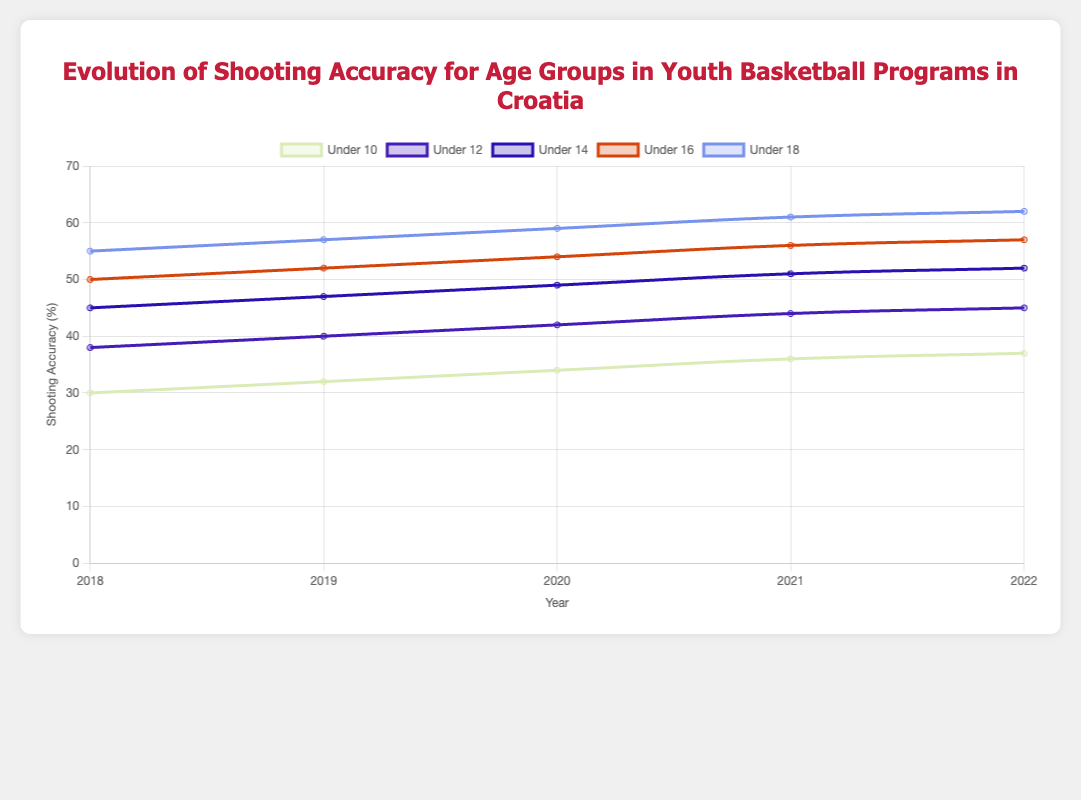What is the overall trend in shooting accuracy for the "Under 10" age group from 2018 to 2022? The "Under 10" age group shows a clear upward trend. Starting at 30% in 2018, it increases to 32% in 2019, 34% in 2020, 36% in 2021, and reaches 37% in 2022.
Answer: Upward trend Which age group has the highest shooting accuracy in 2022? By observing the final data points for each age group in 2022, the "Under 18" age group has the highest shooting accuracy at 62%.
Answer: Under 18 Between "Under 12" and "Under 14" age groups, which showed more improvement in shooting accuracy from 2018 to 2022? The "Under 12" group improved from 38% to 45%, a 7% increase, while the "Under 14" group went from 45% to 52%, also a 7% increase. Both age groups showed equal improvement of 7%.
Answer: Equal improvement What was the average shooting accuracy for the "Under 16" age group over the years 2018 to 2022? The shooting accuracies are 50, 52, 54, 56, and 57 for the given years. Adding these gives (50 + 52 + 54 + 56 + 57) = 269. There are 5 years, so the average is 269 / 5 = 53.8%.
Answer: 53.8% How much did the shooting accuracy for the "Under 18" age group increase between 2020 and 2021? The "Under 18" shooting accuracy in 2020 was 59%, and in 2021 it was 61%. The increase is 61 - 59 = 2%.
Answer: 2% Which age group shows the least improvement in shooting accuracy between 2018 and 2022? The "Under 10" age group improves from 30% to 37%, which is a 7% increase, the least compared to other groups.
Answer: Under 10 Is there any year where all age groups show an improvement in shooting accuracy compared to the previous year? Examining the shooting accuracies year-by-year for each age group reveals that in 2019, all age groups ("Under 10," "Under 12," "Under 14," "Under 16," "Under 18") show an increase compared to 2018. Each group's accuracy rises consistently over the years.
Answer: 2019 What is the difference in shooting accuracy between the "Under 12" and "Under 16" age groups in 2022? In 2022, the "Under 12" age group's shooting accuracy is 45%, and the "Under 16" age group's accuracy is 57%. The difference is 57% - 45% = 12%.
Answer: 12% How does the slope of the line for the "Under 18" age group compare to the "Under 10" age group from 2018 to 2022? The "Under 18" age group's line has a steeper slope, indicating a faster improvement, increasing by 7% from 55% to 62%. The "Under 10" group's slope is less steep, increasing by 7% from 30% to 37%.
Answer: Steeper Which age group consistently has the highest shooting accuracy across all years shown? By looking at each year individually, the "Under 18" age group consistently has the highest shooting accuracy from 2018 to 2022.
Answer: Under 18 